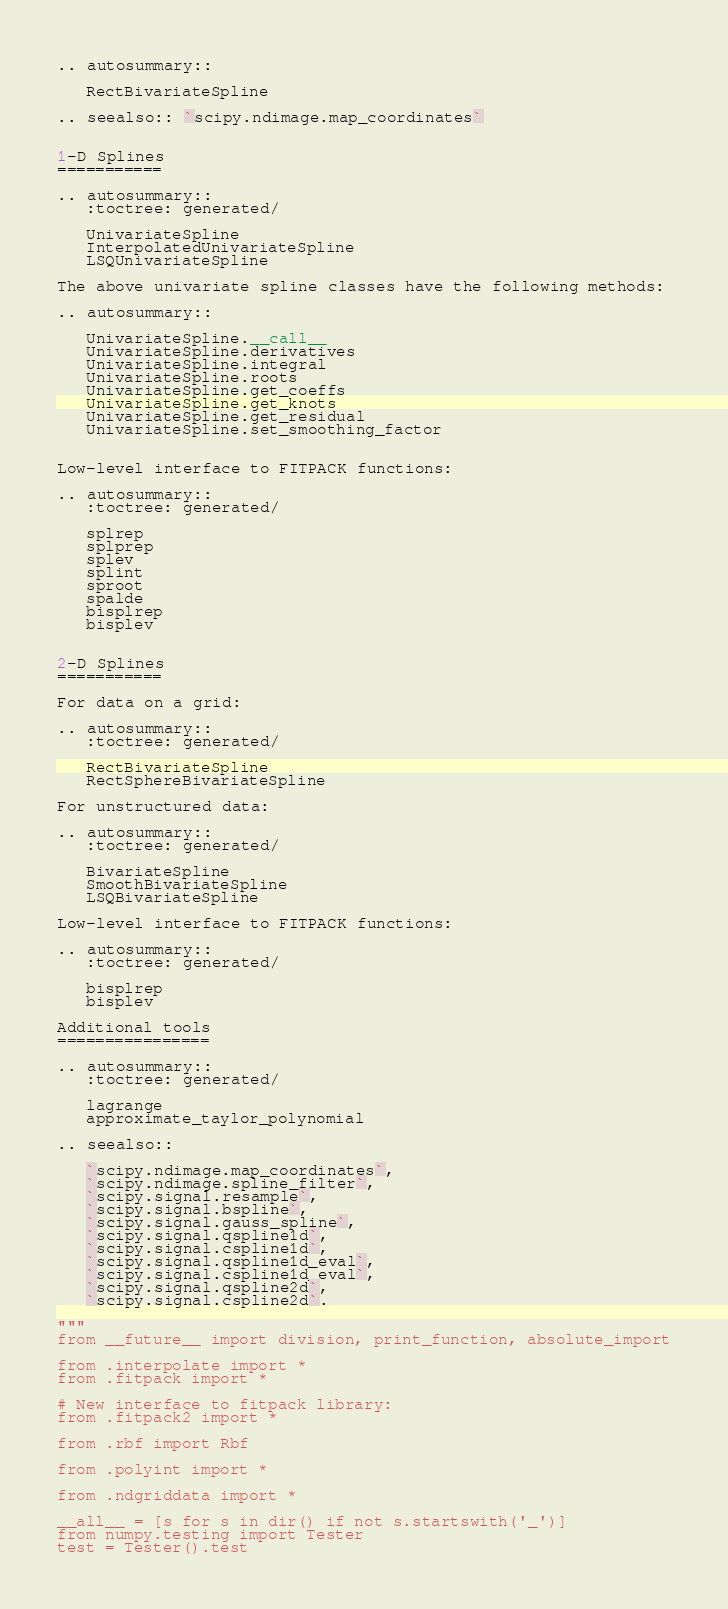<code> <loc_0><loc_0><loc_500><loc_500><_Python_>
.. autosummary::

   RectBivariateSpline

.. seealso:: `scipy.ndimage.map_coordinates`


1-D Splines
===========

.. autosummary::
   :toctree: generated/

   UnivariateSpline
   InterpolatedUnivariateSpline
   LSQUnivariateSpline

The above univariate spline classes have the following methods:

.. autosummary::

   UnivariateSpline.__call__
   UnivariateSpline.derivatives
   UnivariateSpline.integral
   UnivariateSpline.roots
   UnivariateSpline.get_coeffs
   UnivariateSpline.get_knots
   UnivariateSpline.get_residual
   UnivariateSpline.set_smoothing_factor


Low-level interface to FITPACK functions:

.. autosummary::
   :toctree: generated/

   splrep
   splprep
   splev
   splint
   sproot
   spalde
   bisplrep
   bisplev


2-D Splines
===========

For data on a grid:

.. autosummary::
   :toctree: generated/

   RectBivariateSpline
   RectSphereBivariateSpline

For unstructured data:

.. autosummary::
   :toctree: generated/

   BivariateSpline
   SmoothBivariateSpline
   LSQBivariateSpline

Low-level interface to FITPACK functions:

.. autosummary::
   :toctree: generated/

   bisplrep
   bisplev

Additional tools
================

.. autosummary::
   :toctree: generated/

   lagrange
   approximate_taylor_polynomial

.. seealso::

   `scipy.ndimage.map_coordinates`,
   `scipy.ndimage.spline_filter`,
   `scipy.signal.resample`,
   `scipy.signal.bspline`,
   `scipy.signal.gauss_spline`,
   `scipy.signal.qspline1d`,
   `scipy.signal.cspline1d`,
   `scipy.signal.qspline1d_eval`,
   `scipy.signal.cspline1d_eval`,
   `scipy.signal.qspline2d`,
   `scipy.signal.cspline2d`.

"""
from __future__ import division, print_function, absolute_import

from .interpolate import *
from .fitpack import *

# New interface to fitpack library:
from .fitpack2 import *

from .rbf import Rbf

from .polyint import *

from .ndgriddata import *

__all__ = [s for s in dir() if not s.startswith('_')]
from numpy.testing import Tester
test = Tester().test
</code> 